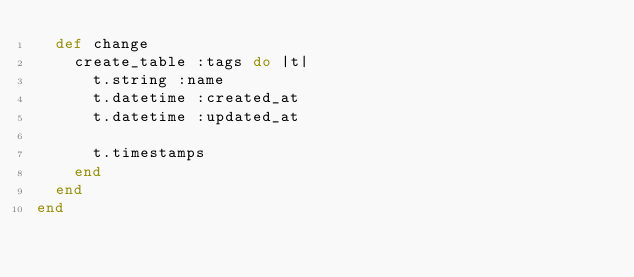<code> <loc_0><loc_0><loc_500><loc_500><_Ruby_>  def change
    create_table :tags do |t|
      t.string :name
      t.datetime :created_at
      t.datetime :updated_at

      t.timestamps
    end
  end
end
</code> 